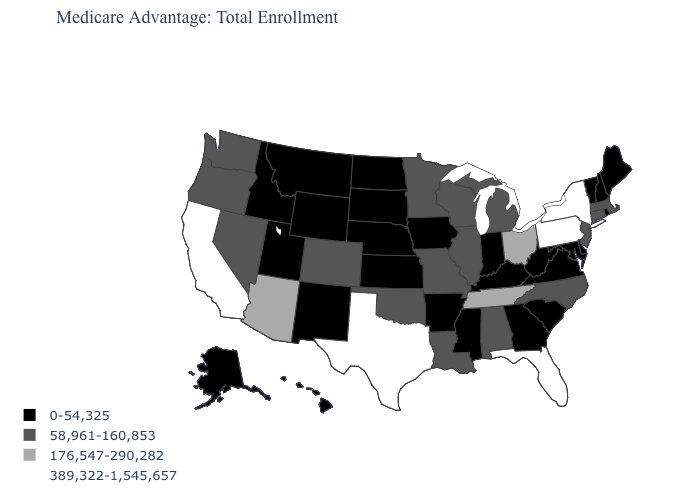Name the states that have a value in the range 389,322-1,545,657?
Answer briefly. California, Florida, New York, Pennsylvania, Texas. What is the value of Pennsylvania?
Short answer required. 389,322-1,545,657. Does the map have missing data?
Concise answer only. No. Does the first symbol in the legend represent the smallest category?
Keep it brief. Yes. What is the value of Arkansas?
Be succinct. 0-54,325. Among the states that border Arizona , which have the lowest value?
Be succinct. New Mexico, Utah. Among the states that border Utah , does Arizona have the highest value?
Write a very short answer. Yes. Which states hav the highest value in the South?
Answer briefly. Florida, Texas. Among the states that border Rhode Island , which have the highest value?
Write a very short answer. Connecticut, Massachusetts. Does Missouri have the lowest value in the MidWest?
Give a very brief answer. No. Does Kansas have the highest value in the MidWest?
Give a very brief answer. No. Which states have the lowest value in the USA?
Quick response, please. Alaska, Arkansas, Delaware, Georgia, Hawaii, Iowa, Idaho, Indiana, Kansas, Kentucky, Maryland, Maine, Mississippi, Montana, North Dakota, Nebraska, New Hampshire, New Mexico, Rhode Island, South Carolina, South Dakota, Utah, Virginia, Vermont, West Virginia, Wyoming. Name the states that have a value in the range 176,547-290,282?
Be succinct. Arizona, Ohio, Tennessee. What is the value of Oklahoma?
Quick response, please. 58,961-160,853. What is the value of California?
Give a very brief answer. 389,322-1,545,657. 